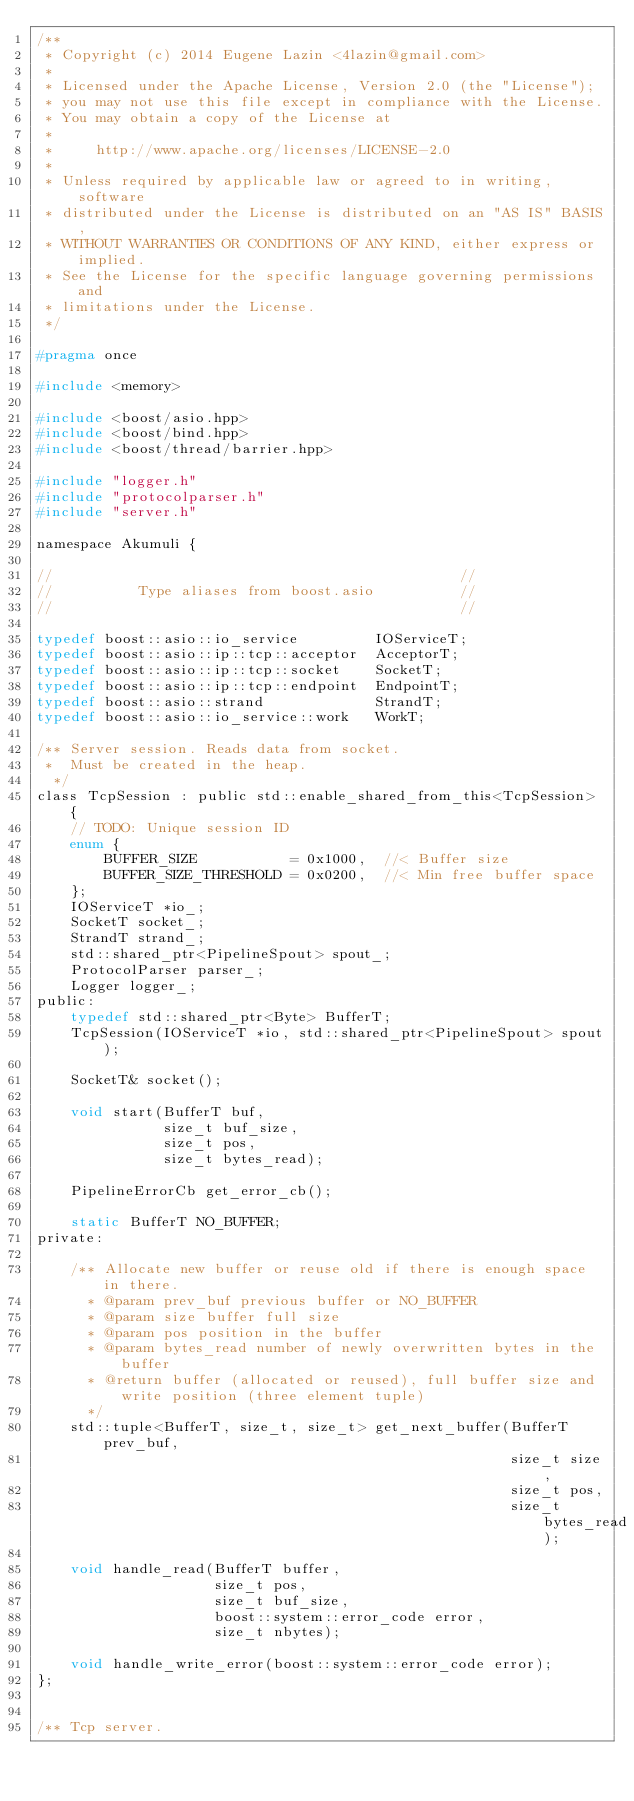Convert code to text. <code><loc_0><loc_0><loc_500><loc_500><_C_>/**
 * Copyright (c) 2014 Eugene Lazin <4lazin@gmail.com>
 *
 * Licensed under the Apache License, Version 2.0 (the "License");
 * you may not use this file except in compliance with the License.
 * You may obtain a copy of the License at
 *
 *     http://www.apache.org/licenses/LICENSE-2.0
 *
 * Unless required by applicable law or agreed to in writing, software
 * distributed under the License is distributed on an "AS IS" BASIS,
 * WITHOUT WARRANTIES OR CONDITIONS OF ANY KIND, either express or implied.
 * See the License for the specific language governing permissions and
 * limitations under the License.
 */

#pragma once

#include <memory>

#include <boost/asio.hpp>
#include <boost/bind.hpp>
#include <boost/thread/barrier.hpp>

#include "logger.h"
#include "protocolparser.h"
#include "server.h"

namespace Akumuli {

//                                                //
//          Type aliases from boost.asio          //
//                                                //

typedef boost::asio::io_service         IOServiceT;
typedef boost::asio::ip::tcp::acceptor  AcceptorT;
typedef boost::asio::ip::tcp::socket    SocketT;
typedef boost::asio::ip::tcp::endpoint  EndpointT;
typedef boost::asio::strand             StrandT;
typedef boost::asio::io_service::work   WorkT;

/** Server session. Reads data from socket.
 *  Must be created in the heap.
  */
class TcpSession : public std::enable_shared_from_this<TcpSession> {
    // TODO: Unique session ID
    enum {
        BUFFER_SIZE           = 0x1000,  //< Buffer size
        BUFFER_SIZE_THRESHOLD = 0x0200,  //< Min free buffer space
    };
    IOServiceT *io_;
    SocketT socket_;
    StrandT strand_;
    std::shared_ptr<PipelineSpout> spout_;
    ProtocolParser parser_;
    Logger logger_;
public:
    typedef std::shared_ptr<Byte> BufferT;
    TcpSession(IOServiceT *io, std::shared_ptr<PipelineSpout> spout);

    SocketT& socket();

    void start(BufferT buf,
               size_t buf_size,
               size_t pos,
               size_t bytes_read);

    PipelineErrorCb get_error_cb();

    static BufferT NO_BUFFER;
private:

    /** Allocate new buffer or reuse old if there is enough space in there.
      * @param prev_buf previous buffer or NO_BUFFER
      * @param size buffer full size
      * @param pos position in the buffer
      * @param bytes_read number of newly overwritten bytes in the buffer
      * @return buffer (allocated or reused), full buffer size and write position (three element tuple)
      */
    std::tuple<BufferT, size_t, size_t> get_next_buffer(BufferT prev_buf,
                                                        size_t size,
                                                        size_t pos,
                                                        size_t bytes_read);

    void handle_read(BufferT buffer,
                     size_t pos,
                     size_t buf_size,
                     boost::system::error_code error,
                     size_t nbytes);

    void handle_write_error(boost::system::error_code error);
};


/** Tcp server.</code> 